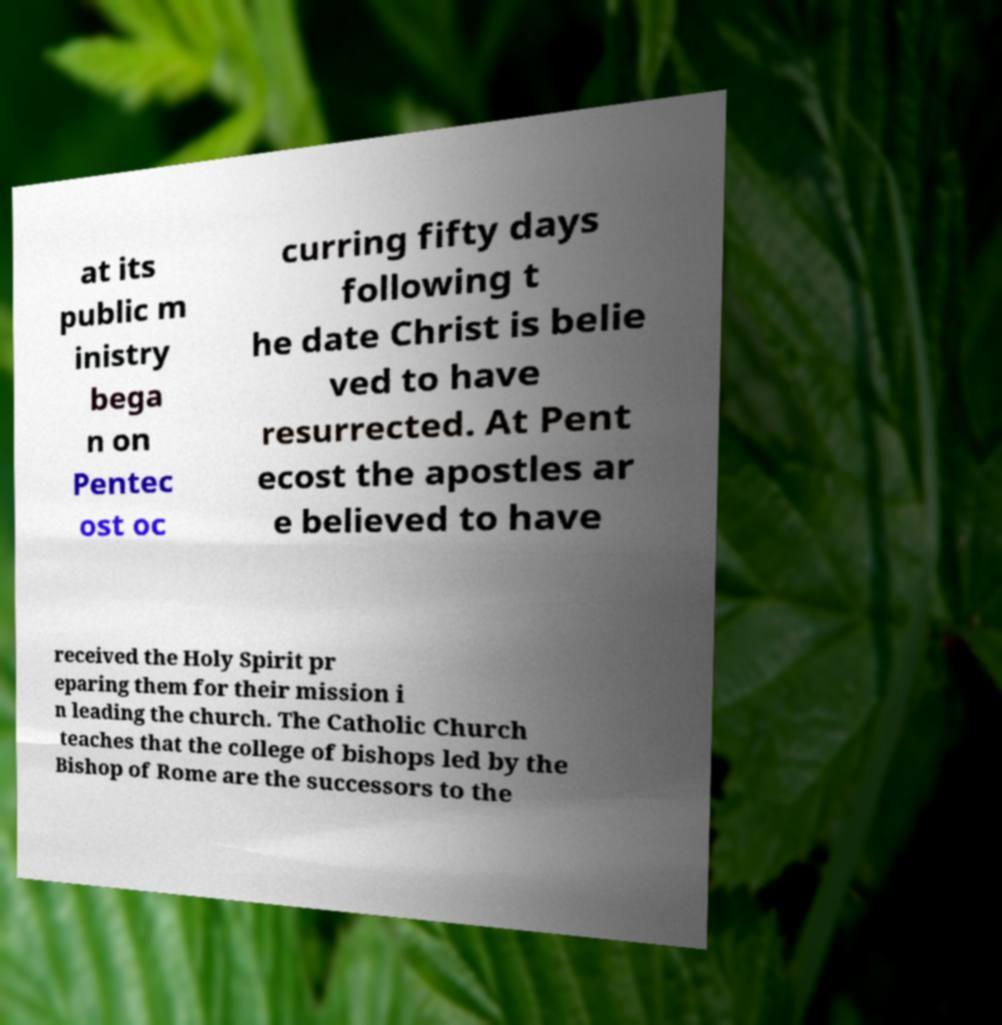Could you extract and type out the text from this image? at its public m inistry bega n on Pentec ost oc curring fifty days following t he date Christ is belie ved to have resurrected. At Pent ecost the apostles ar e believed to have received the Holy Spirit pr eparing them for their mission i n leading the church. The Catholic Church teaches that the college of bishops led by the Bishop of Rome are the successors to the 